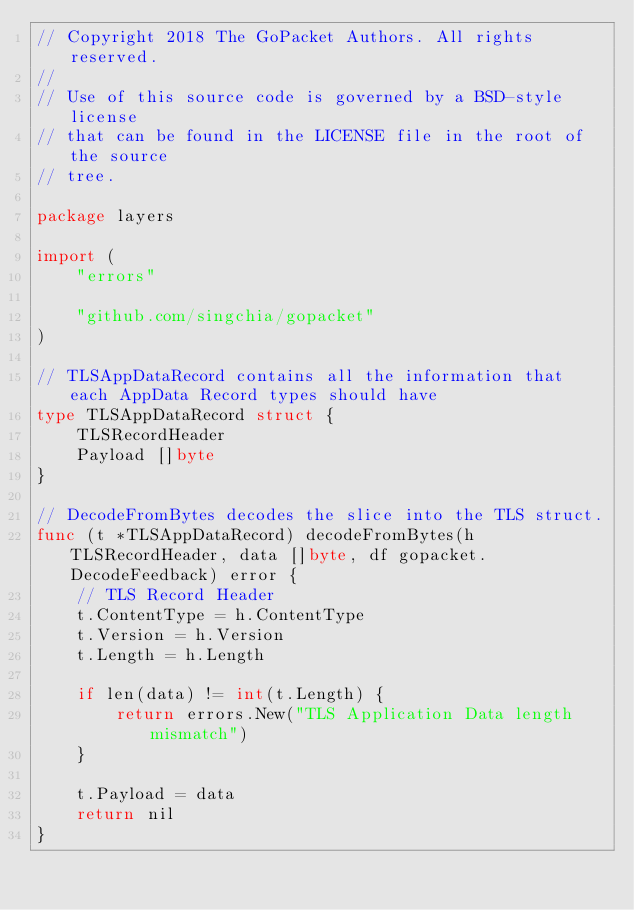Convert code to text. <code><loc_0><loc_0><loc_500><loc_500><_Go_>// Copyright 2018 The GoPacket Authors. All rights reserved.
//
// Use of this source code is governed by a BSD-style license
// that can be found in the LICENSE file in the root of the source
// tree.

package layers

import (
	"errors"

	"github.com/singchia/gopacket"
)

// TLSAppDataRecord contains all the information that each AppData Record types should have
type TLSAppDataRecord struct {
	TLSRecordHeader
	Payload []byte
}

// DecodeFromBytes decodes the slice into the TLS struct.
func (t *TLSAppDataRecord) decodeFromBytes(h TLSRecordHeader, data []byte, df gopacket.DecodeFeedback) error {
	// TLS Record Header
	t.ContentType = h.ContentType
	t.Version = h.Version
	t.Length = h.Length

	if len(data) != int(t.Length) {
		return errors.New("TLS Application Data length mismatch")
	}

	t.Payload = data
	return nil
}
</code> 